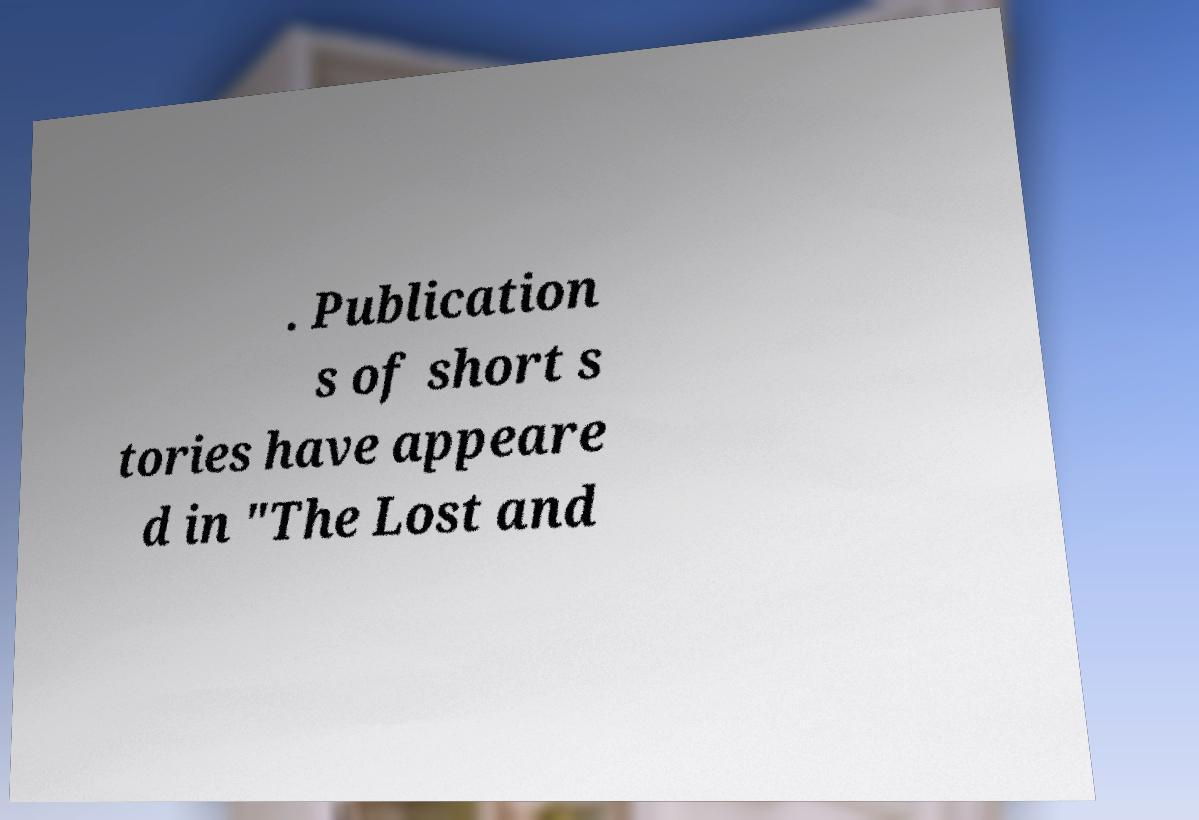Can you accurately transcribe the text from the provided image for me? . Publication s of short s tories have appeare d in "The Lost and 